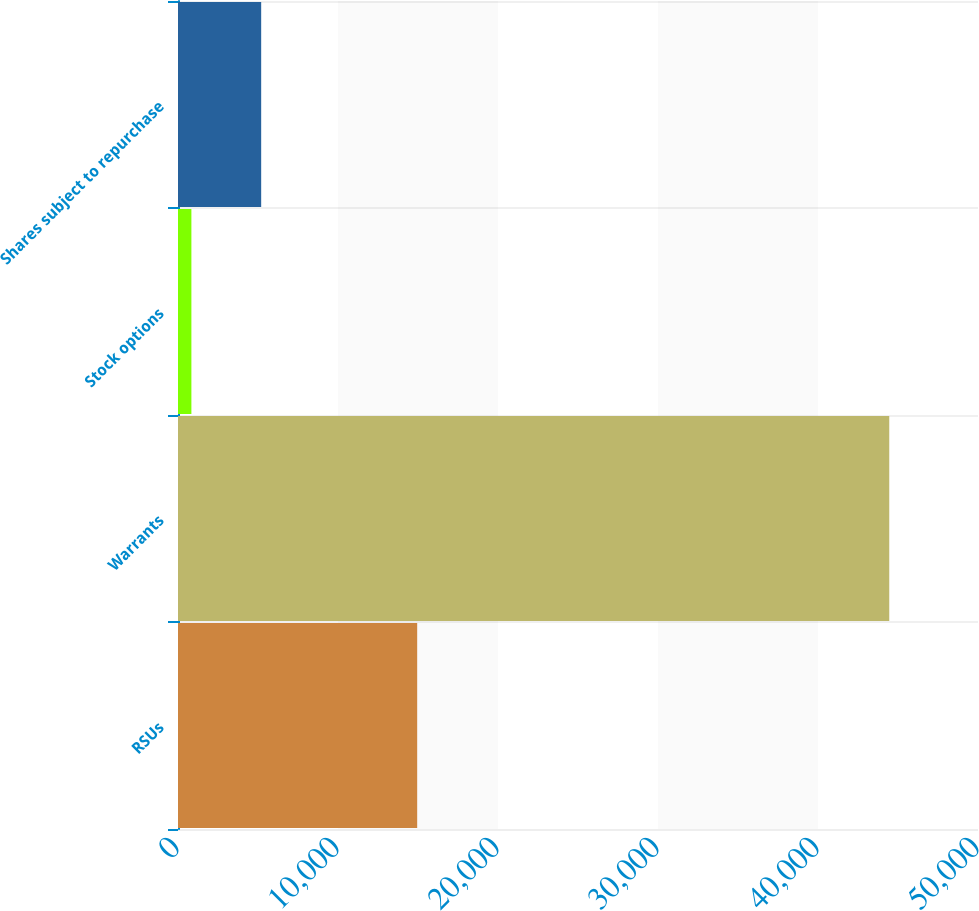<chart> <loc_0><loc_0><loc_500><loc_500><bar_chart><fcel>RSUs<fcel>Warrants<fcel>Stock options<fcel>Shares subject to repurchase<nl><fcel>14949<fcel>44454<fcel>837<fcel>5198.7<nl></chart> 